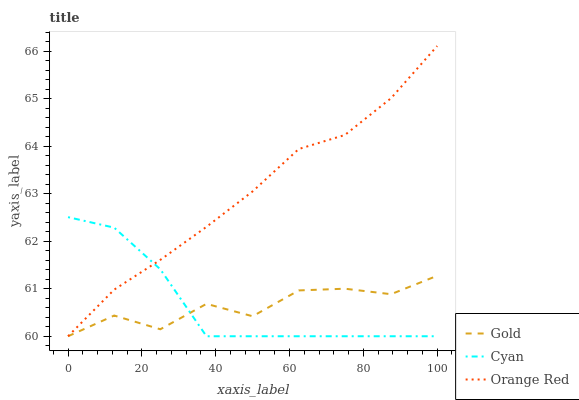Does Cyan have the minimum area under the curve?
Answer yes or no. Yes. Does Orange Red have the maximum area under the curve?
Answer yes or no. Yes. Does Gold have the minimum area under the curve?
Answer yes or no. No. Does Gold have the maximum area under the curve?
Answer yes or no. No. Is Orange Red the smoothest?
Answer yes or no. Yes. Is Gold the roughest?
Answer yes or no. Yes. Is Gold the smoothest?
Answer yes or no. No. Is Orange Red the roughest?
Answer yes or no. No. Does Cyan have the lowest value?
Answer yes or no. Yes. Does Orange Red have the highest value?
Answer yes or no. Yes. Does Gold have the highest value?
Answer yes or no. No. Does Orange Red intersect Gold?
Answer yes or no. Yes. Is Orange Red less than Gold?
Answer yes or no. No. Is Orange Red greater than Gold?
Answer yes or no. No. 